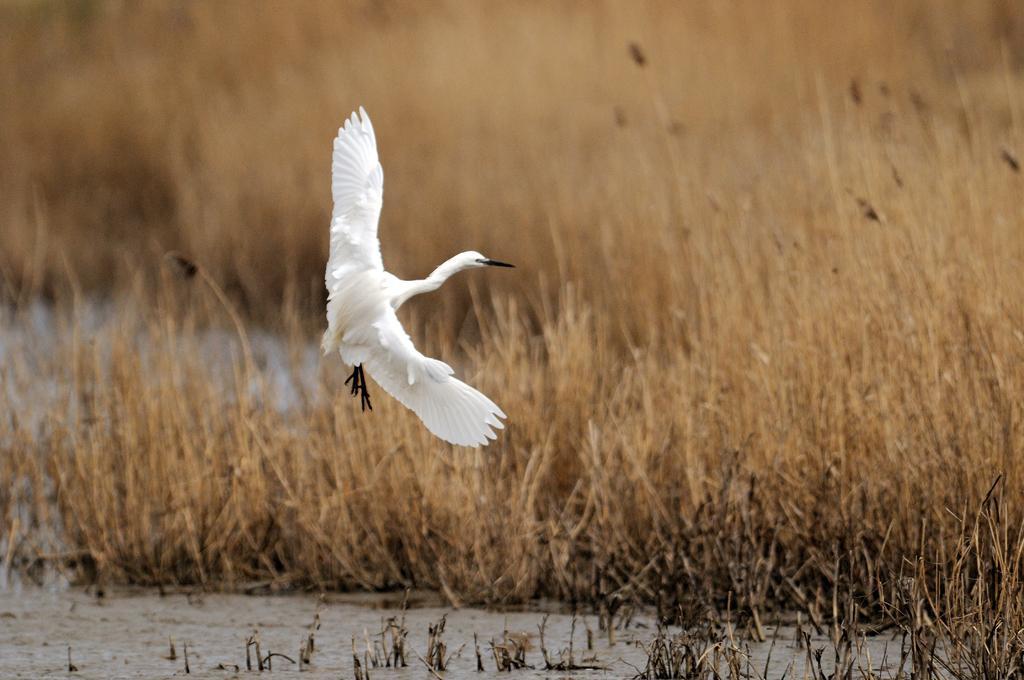Describe this image in one or two sentences. In this image I can see a white color bird flying. Back I can see dry grass and water. 